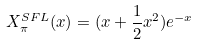<formula> <loc_0><loc_0><loc_500><loc_500>X _ { \pi } ^ { S F L } ( x ) = ( x + \frac { 1 } { 2 } x ^ { 2 } ) e ^ { - x }</formula> 